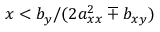Convert formula to latex. <formula><loc_0><loc_0><loc_500><loc_500>x < b _ { y } / ( 2 a _ { x x } ^ { 2 } \mp b _ { x y } )</formula> 